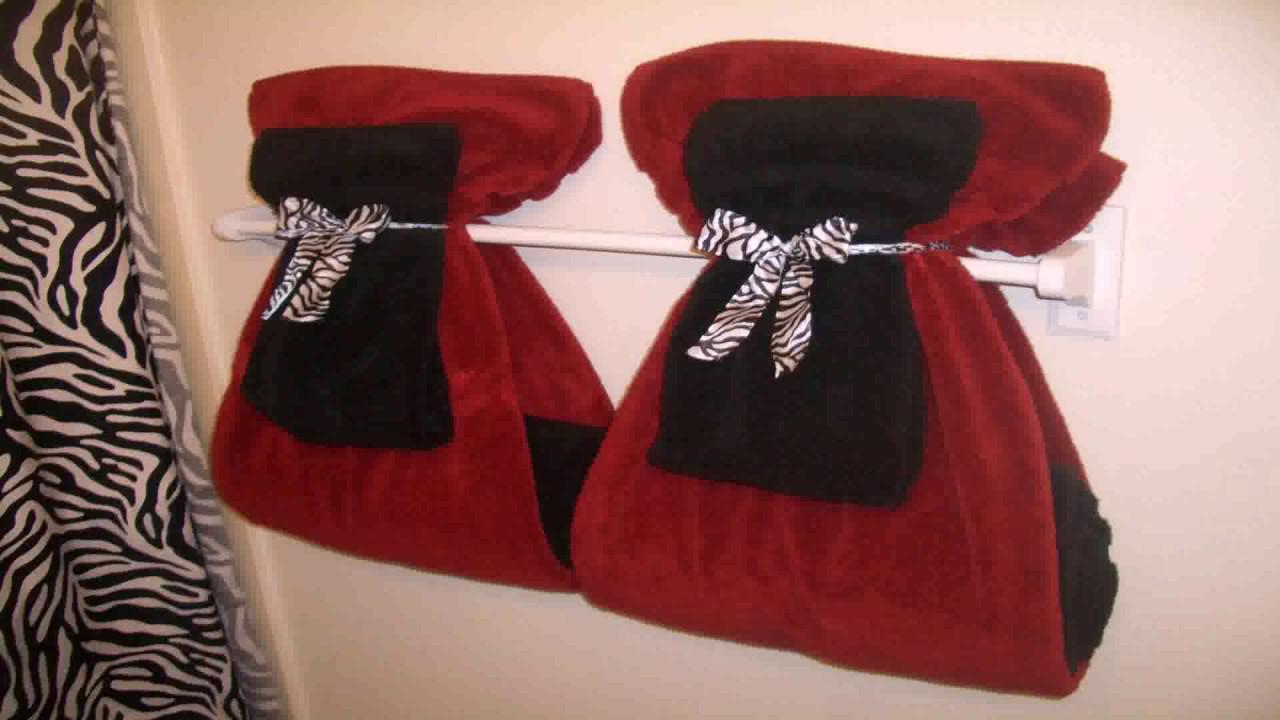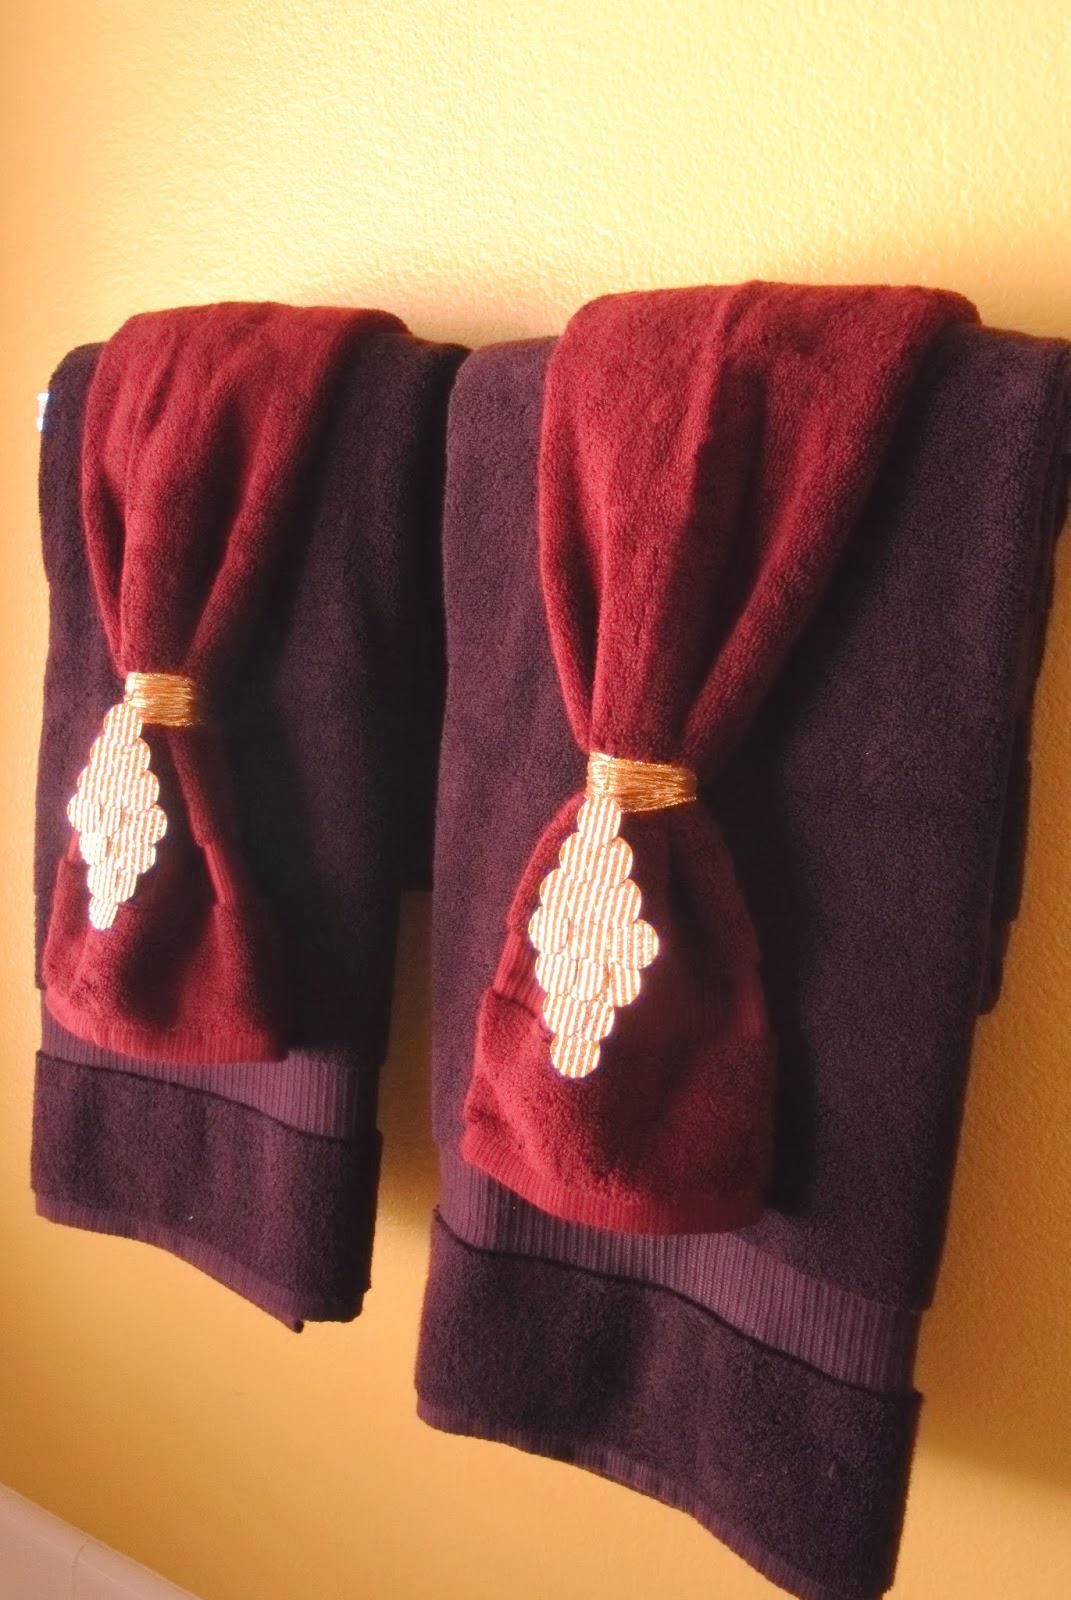The first image is the image on the left, the second image is the image on the right. Analyze the images presented: Is the assertion "Towels are hung on the wall under pictures." valid? Answer yes or no. No. 